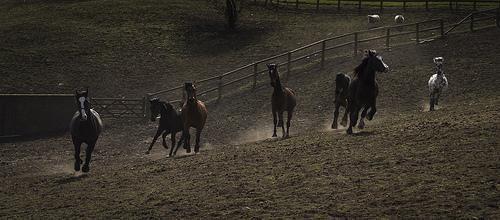How many horses are shown?
Give a very brief answer. 7. 